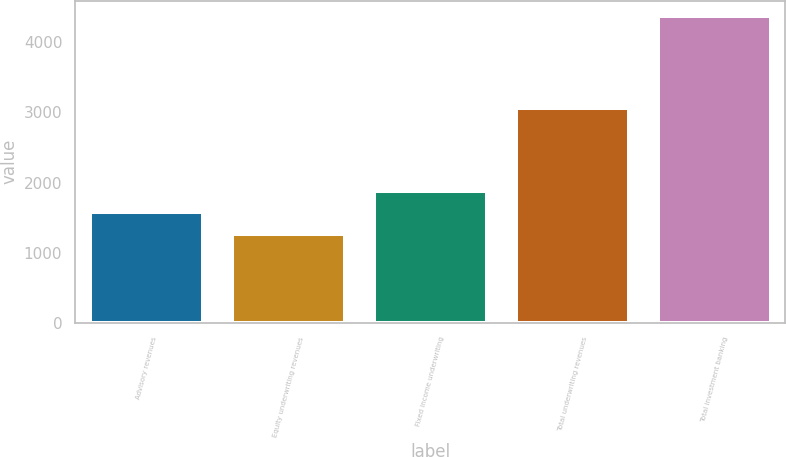Convert chart. <chart><loc_0><loc_0><loc_500><loc_500><bar_chart><fcel>Advisory revenues<fcel>Equity underwriting revenues<fcel>Fixed income underwriting<fcel>Total underwriting revenues<fcel>Total investment banking<nl><fcel>1573.5<fcel>1262<fcel>1885<fcel>3067<fcel>4377<nl></chart> 